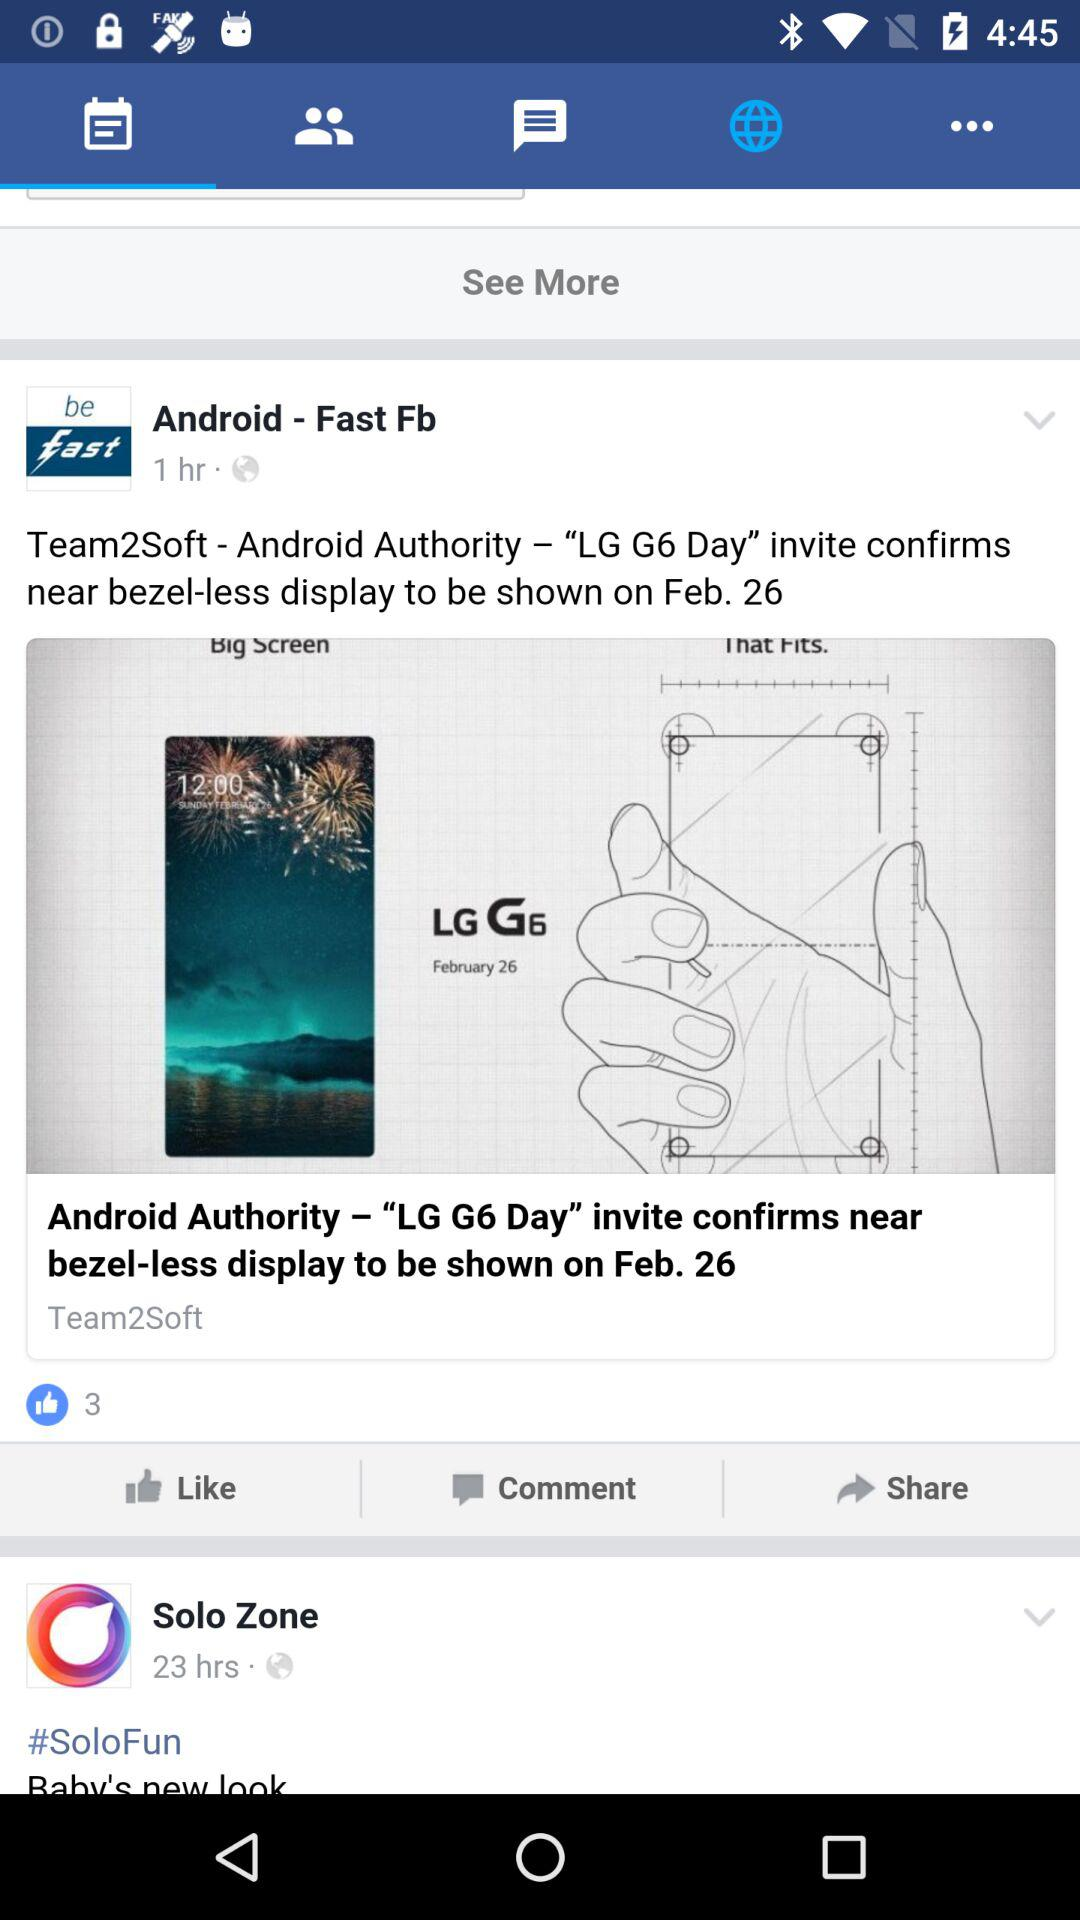What is the number of likes on the post posted by "Android - Fast Fb"? The number of likes is 3. 